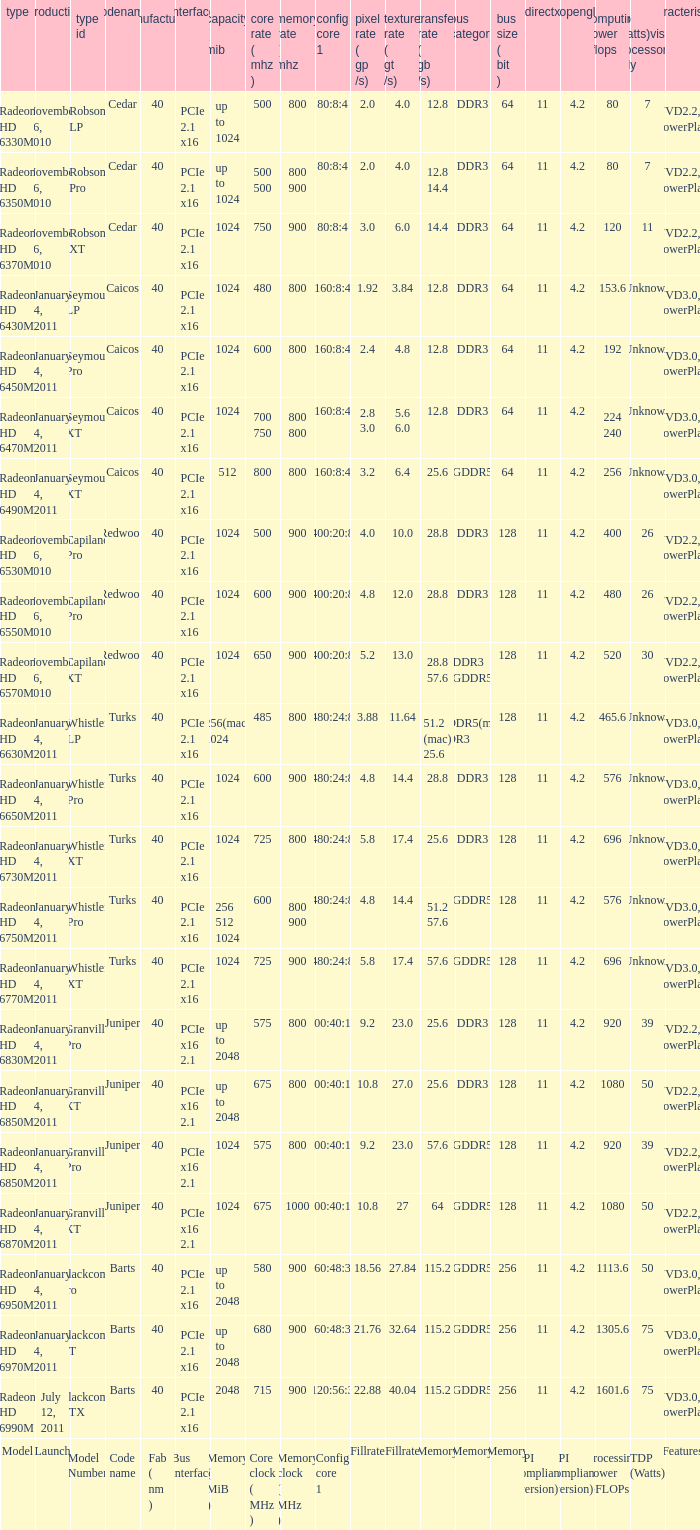How many values for fab(nm) if the model number is Whistler LP? 1.0. 